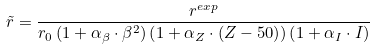Convert formula to latex. <formula><loc_0><loc_0><loc_500><loc_500>\tilde { r } = \frac { r ^ { e x p } } { r _ { 0 } \left ( 1 + \alpha _ { \beta } \cdot \beta ^ { 2 } \right ) \left ( 1 + \alpha _ { Z } \cdot \left ( Z - 5 0 \right ) \right ) \left ( 1 + \alpha _ { I } \cdot I \right ) }</formula> 